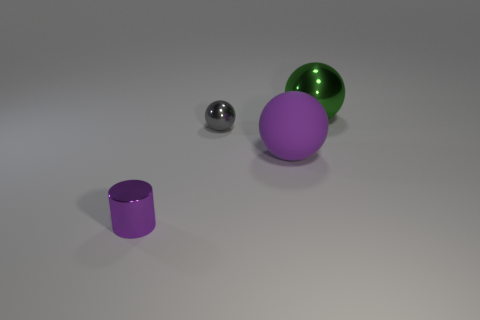Subtract all large spheres. How many spheres are left? 1 Add 2 big green shiny balls. How many objects exist? 6 Subtract all brown shiny blocks. Subtract all gray metallic things. How many objects are left? 3 Add 1 small things. How many small things are left? 3 Add 3 small purple things. How many small purple things exist? 4 Subtract 1 purple cylinders. How many objects are left? 3 Subtract all balls. How many objects are left? 1 